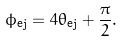<formula> <loc_0><loc_0><loc_500><loc_500>\phi _ { \text {ej} } = 4 \theta _ { \text {ej} } + \frac { \pi } { 2 } .</formula> 